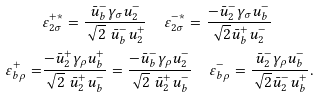<formula> <loc_0><loc_0><loc_500><loc_500>& \varepsilon _ { 2 \sigma } ^ { + * } = \frac { \bar { u } _ { b } ^ { - } \gamma _ { \sigma } u _ { 2 } ^ { - } } { \sqrt { 2 } \ \bar { u } _ { b } ^ { - } u _ { 2 } ^ { + } } \quad \varepsilon _ { 2 \sigma } ^ { - * } = \frac { - \bar { u } _ { 2 } ^ { - } \gamma _ { \sigma } u _ { b } ^ { - } } { \sqrt { 2 } \bar { u } _ { b } ^ { + } u _ { 2 } ^ { - } } \\ \varepsilon _ { b \rho } ^ { + } = & \frac { - \bar { u } _ { 2 } ^ { + } \gamma _ { \rho } u _ { b } ^ { + } } { \sqrt { 2 } \ \bar { u } _ { 2 } ^ { + } u _ { b } ^ { - } } = \frac { - \bar { u } _ { b } ^ { - } \gamma _ { \rho } u _ { 2 } ^ { - } } { \sqrt { 2 } \ \bar { u } _ { 2 } ^ { + } u _ { b } ^ { - } } \quad \varepsilon _ { b \rho } ^ { - } = \frac { \bar { u } _ { 2 } ^ { - } \gamma _ { \rho } u _ { b } ^ { - } } { \sqrt { 2 } \bar { u } _ { 2 } ^ { - } u _ { b } ^ { + } } .</formula> 